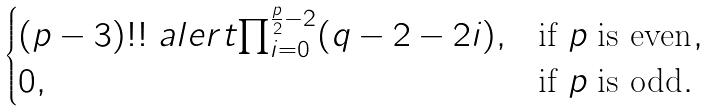Convert formula to latex. <formula><loc_0><loc_0><loc_500><loc_500>\begin{cases} ( p - 3 ) ! ! \ a l e r t { \prod _ { i = 0 } ^ { \frac { p } { 2 } - 2 } } ( q - 2 - 2 i ) , & \text {if $p$ is even} , \\ 0 , & \text {if $p$ is odd} . \end{cases}</formula> 